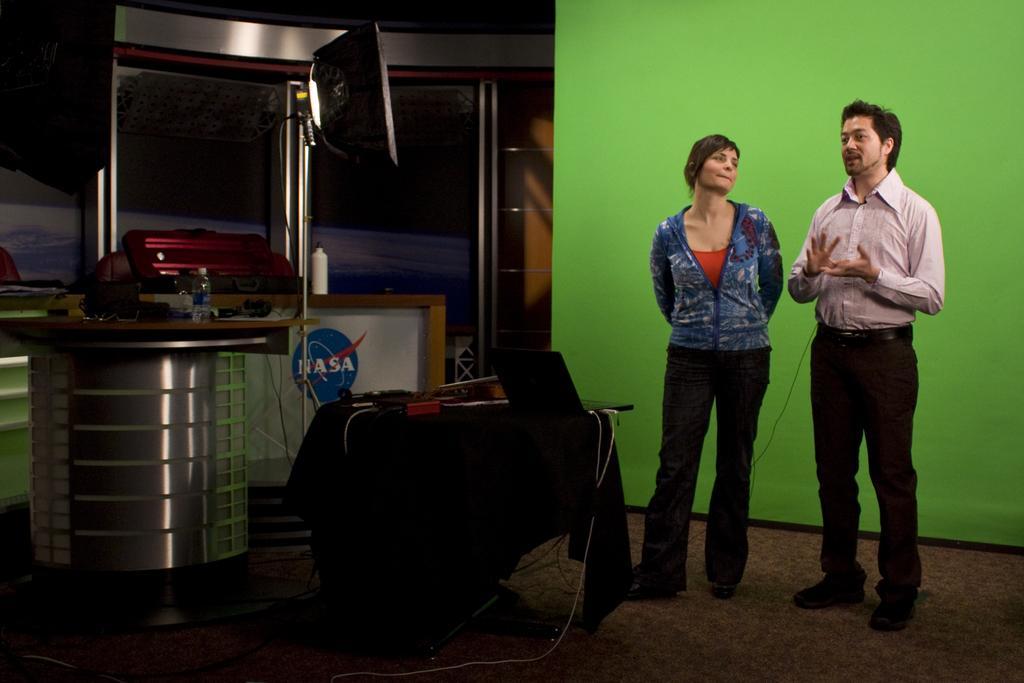How would you summarize this image in a sentence or two? In this image there is a man and a woman standing on the floor and behind these persons there is a green color wall. Image also consists of a laptop, bottles and also tables. We can also see windows and also light. 